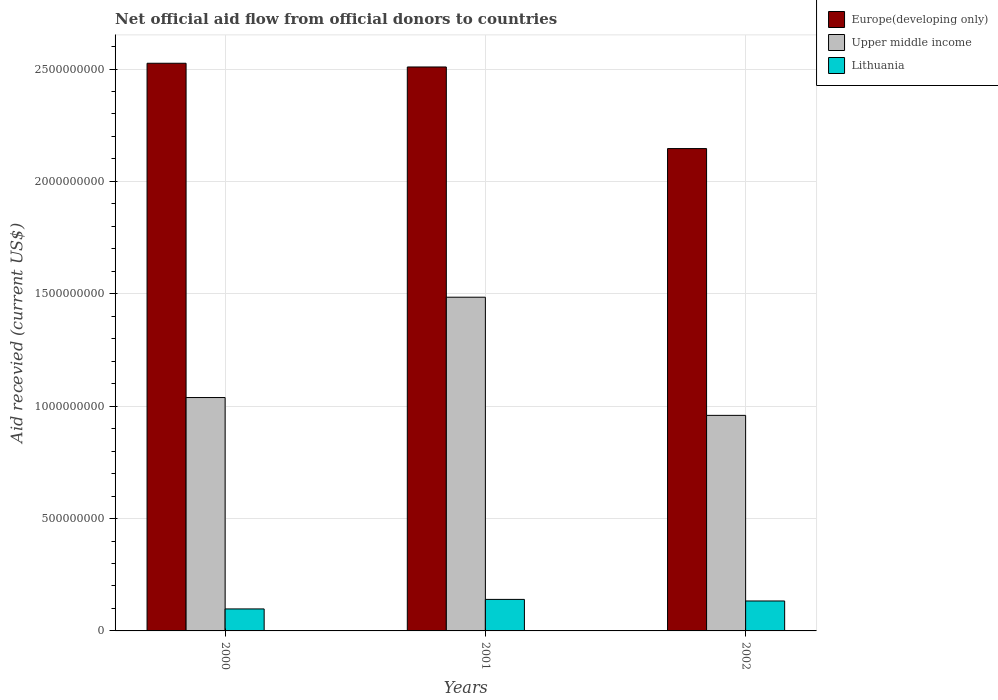How many groups of bars are there?
Offer a very short reply. 3. Are the number of bars per tick equal to the number of legend labels?
Ensure brevity in your answer.  Yes. What is the label of the 1st group of bars from the left?
Make the answer very short. 2000. In how many cases, is the number of bars for a given year not equal to the number of legend labels?
Ensure brevity in your answer.  0. What is the total aid received in Europe(developing only) in 2002?
Your answer should be very brief. 2.15e+09. Across all years, what is the maximum total aid received in Europe(developing only)?
Keep it short and to the point. 2.53e+09. Across all years, what is the minimum total aid received in Upper middle income?
Offer a very short reply. 9.59e+08. In which year was the total aid received in Upper middle income minimum?
Your response must be concise. 2002. What is the total total aid received in Upper middle income in the graph?
Offer a terse response. 3.48e+09. What is the difference between the total aid received in Lithuania in 2000 and that in 2002?
Your answer should be very brief. -3.54e+07. What is the difference between the total aid received in Lithuania in 2000 and the total aid received in Upper middle income in 2002?
Make the answer very short. -8.61e+08. What is the average total aid received in Europe(developing only) per year?
Ensure brevity in your answer.  2.39e+09. In the year 2002, what is the difference between the total aid received in Lithuania and total aid received in Europe(developing only)?
Provide a succinct answer. -2.01e+09. In how many years, is the total aid received in Lithuania greater than 1400000000 US$?
Provide a succinct answer. 0. What is the ratio of the total aid received in Upper middle income in 2000 to that in 2002?
Ensure brevity in your answer.  1.08. What is the difference between the highest and the second highest total aid received in Europe(developing only)?
Your answer should be very brief. 1.65e+07. What is the difference between the highest and the lowest total aid received in Upper middle income?
Ensure brevity in your answer.  5.26e+08. In how many years, is the total aid received in Lithuania greater than the average total aid received in Lithuania taken over all years?
Your answer should be very brief. 2. What does the 2nd bar from the left in 2002 represents?
Your answer should be compact. Upper middle income. What does the 3rd bar from the right in 2000 represents?
Provide a short and direct response. Europe(developing only). Is it the case that in every year, the sum of the total aid received in Upper middle income and total aid received in Europe(developing only) is greater than the total aid received in Lithuania?
Make the answer very short. Yes. Are all the bars in the graph horizontal?
Keep it short and to the point. No. How many years are there in the graph?
Make the answer very short. 3. Are the values on the major ticks of Y-axis written in scientific E-notation?
Offer a terse response. No. Does the graph contain any zero values?
Your answer should be very brief. No. How many legend labels are there?
Your response must be concise. 3. What is the title of the graph?
Your answer should be very brief. Net official aid flow from official donors to countries. Does "Belgium" appear as one of the legend labels in the graph?
Provide a succinct answer. No. What is the label or title of the Y-axis?
Provide a short and direct response. Aid recevied (current US$). What is the Aid recevied (current US$) of Europe(developing only) in 2000?
Provide a succinct answer. 2.53e+09. What is the Aid recevied (current US$) of Upper middle income in 2000?
Give a very brief answer. 1.04e+09. What is the Aid recevied (current US$) in Lithuania in 2000?
Give a very brief answer. 9.78e+07. What is the Aid recevied (current US$) in Europe(developing only) in 2001?
Provide a succinct answer. 2.51e+09. What is the Aid recevied (current US$) of Upper middle income in 2001?
Ensure brevity in your answer.  1.48e+09. What is the Aid recevied (current US$) of Lithuania in 2001?
Provide a short and direct response. 1.40e+08. What is the Aid recevied (current US$) of Europe(developing only) in 2002?
Your response must be concise. 2.15e+09. What is the Aid recevied (current US$) in Upper middle income in 2002?
Ensure brevity in your answer.  9.59e+08. What is the Aid recevied (current US$) of Lithuania in 2002?
Offer a terse response. 1.33e+08. Across all years, what is the maximum Aid recevied (current US$) of Europe(developing only)?
Provide a succinct answer. 2.53e+09. Across all years, what is the maximum Aid recevied (current US$) in Upper middle income?
Offer a terse response. 1.48e+09. Across all years, what is the maximum Aid recevied (current US$) of Lithuania?
Provide a short and direct response. 1.40e+08. Across all years, what is the minimum Aid recevied (current US$) in Europe(developing only)?
Make the answer very short. 2.15e+09. Across all years, what is the minimum Aid recevied (current US$) of Upper middle income?
Give a very brief answer. 9.59e+08. Across all years, what is the minimum Aid recevied (current US$) of Lithuania?
Give a very brief answer. 9.78e+07. What is the total Aid recevied (current US$) in Europe(developing only) in the graph?
Provide a short and direct response. 7.18e+09. What is the total Aid recevied (current US$) of Upper middle income in the graph?
Offer a terse response. 3.48e+09. What is the total Aid recevied (current US$) of Lithuania in the graph?
Offer a very short reply. 3.71e+08. What is the difference between the Aid recevied (current US$) of Europe(developing only) in 2000 and that in 2001?
Give a very brief answer. 1.65e+07. What is the difference between the Aid recevied (current US$) of Upper middle income in 2000 and that in 2001?
Give a very brief answer. -4.46e+08. What is the difference between the Aid recevied (current US$) of Lithuania in 2000 and that in 2001?
Your answer should be compact. -4.24e+07. What is the difference between the Aid recevied (current US$) of Europe(developing only) in 2000 and that in 2002?
Offer a terse response. 3.80e+08. What is the difference between the Aid recevied (current US$) in Upper middle income in 2000 and that in 2002?
Your response must be concise. 7.93e+07. What is the difference between the Aid recevied (current US$) in Lithuania in 2000 and that in 2002?
Keep it short and to the point. -3.54e+07. What is the difference between the Aid recevied (current US$) in Europe(developing only) in 2001 and that in 2002?
Your answer should be very brief. 3.63e+08. What is the difference between the Aid recevied (current US$) in Upper middle income in 2001 and that in 2002?
Give a very brief answer. 5.26e+08. What is the difference between the Aid recevied (current US$) of Lithuania in 2001 and that in 2002?
Keep it short and to the point. 7.02e+06. What is the difference between the Aid recevied (current US$) of Europe(developing only) in 2000 and the Aid recevied (current US$) of Upper middle income in 2001?
Your answer should be very brief. 1.04e+09. What is the difference between the Aid recevied (current US$) of Europe(developing only) in 2000 and the Aid recevied (current US$) of Lithuania in 2001?
Keep it short and to the point. 2.39e+09. What is the difference between the Aid recevied (current US$) of Upper middle income in 2000 and the Aid recevied (current US$) of Lithuania in 2001?
Offer a very short reply. 8.98e+08. What is the difference between the Aid recevied (current US$) in Europe(developing only) in 2000 and the Aid recevied (current US$) in Upper middle income in 2002?
Ensure brevity in your answer.  1.57e+09. What is the difference between the Aid recevied (current US$) of Europe(developing only) in 2000 and the Aid recevied (current US$) of Lithuania in 2002?
Provide a succinct answer. 2.39e+09. What is the difference between the Aid recevied (current US$) of Upper middle income in 2000 and the Aid recevied (current US$) of Lithuania in 2002?
Keep it short and to the point. 9.05e+08. What is the difference between the Aid recevied (current US$) in Europe(developing only) in 2001 and the Aid recevied (current US$) in Upper middle income in 2002?
Offer a terse response. 1.55e+09. What is the difference between the Aid recevied (current US$) of Europe(developing only) in 2001 and the Aid recevied (current US$) of Lithuania in 2002?
Offer a terse response. 2.38e+09. What is the difference between the Aid recevied (current US$) in Upper middle income in 2001 and the Aid recevied (current US$) in Lithuania in 2002?
Give a very brief answer. 1.35e+09. What is the average Aid recevied (current US$) in Europe(developing only) per year?
Your answer should be compact. 2.39e+09. What is the average Aid recevied (current US$) of Upper middle income per year?
Offer a terse response. 1.16e+09. What is the average Aid recevied (current US$) in Lithuania per year?
Your answer should be very brief. 1.24e+08. In the year 2000, what is the difference between the Aid recevied (current US$) in Europe(developing only) and Aid recevied (current US$) in Upper middle income?
Make the answer very short. 1.49e+09. In the year 2000, what is the difference between the Aid recevied (current US$) of Europe(developing only) and Aid recevied (current US$) of Lithuania?
Provide a succinct answer. 2.43e+09. In the year 2000, what is the difference between the Aid recevied (current US$) in Upper middle income and Aid recevied (current US$) in Lithuania?
Your answer should be compact. 9.40e+08. In the year 2001, what is the difference between the Aid recevied (current US$) of Europe(developing only) and Aid recevied (current US$) of Upper middle income?
Make the answer very short. 1.02e+09. In the year 2001, what is the difference between the Aid recevied (current US$) in Europe(developing only) and Aid recevied (current US$) in Lithuania?
Provide a short and direct response. 2.37e+09. In the year 2001, what is the difference between the Aid recevied (current US$) in Upper middle income and Aid recevied (current US$) in Lithuania?
Provide a succinct answer. 1.34e+09. In the year 2002, what is the difference between the Aid recevied (current US$) in Europe(developing only) and Aid recevied (current US$) in Upper middle income?
Your answer should be compact. 1.19e+09. In the year 2002, what is the difference between the Aid recevied (current US$) of Europe(developing only) and Aid recevied (current US$) of Lithuania?
Provide a short and direct response. 2.01e+09. In the year 2002, what is the difference between the Aid recevied (current US$) in Upper middle income and Aid recevied (current US$) in Lithuania?
Keep it short and to the point. 8.26e+08. What is the ratio of the Aid recevied (current US$) in Europe(developing only) in 2000 to that in 2001?
Keep it short and to the point. 1.01. What is the ratio of the Aid recevied (current US$) in Upper middle income in 2000 to that in 2001?
Make the answer very short. 0.7. What is the ratio of the Aid recevied (current US$) in Lithuania in 2000 to that in 2001?
Give a very brief answer. 0.7. What is the ratio of the Aid recevied (current US$) of Europe(developing only) in 2000 to that in 2002?
Your answer should be compact. 1.18. What is the ratio of the Aid recevied (current US$) of Upper middle income in 2000 to that in 2002?
Ensure brevity in your answer.  1.08. What is the ratio of the Aid recevied (current US$) in Lithuania in 2000 to that in 2002?
Offer a very short reply. 0.73. What is the ratio of the Aid recevied (current US$) in Europe(developing only) in 2001 to that in 2002?
Give a very brief answer. 1.17. What is the ratio of the Aid recevied (current US$) of Upper middle income in 2001 to that in 2002?
Give a very brief answer. 1.55. What is the ratio of the Aid recevied (current US$) in Lithuania in 2001 to that in 2002?
Your answer should be very brief. 1.05. What is the difference between the highest and the second highest Aid recevied (current US$) in Europe(developing only)?
Your answer should be compact. 1.65e+07. What is the difference between the highest and the second highest Aid recevied (current US$) of Upper middle income?
Keep it short and to the point. 4.46e+08. What is the difference between the highest and the second highest Aid recevied (current US$) of Lithuania?
Your answer should be very brief. 7.02e+06. What is the difference between the highest and the lowest Aid recevied (current US$) of Europe(developing only)?
Provide a short and direct response. 3.80e+08. What is the difference between the highest and the lowest Aid recevied (current US$) in Upper middle income?
Provide a short and direct response. 5.26e+08. What is the difference between the highest and the lowest Aid recevied (current US$) of Lithuania?
Offer a very short reply. 4.24e+07. 